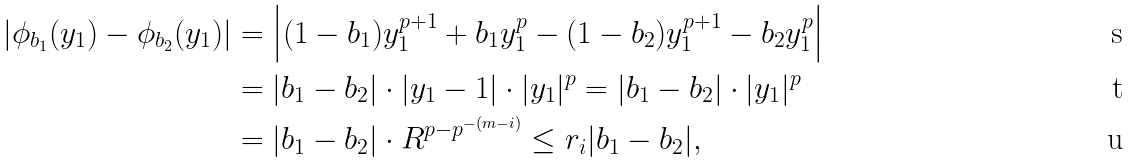<formula> <loc_0><loc_0><loc_500><loc_500>\left | \phi _ { b _ { 1 } } ( y _ { 1 } ) - \phi _ { b _ { 2 } } ( y _ { 1 } ) \right | & = \left | ( 1 - b _ { 1 } ) y _ { 1 } ^ { p + 1 } + b _ { 1 } y _ { 1 } ^ { p } - ( 1 - b _ { 2 } ) y _ { 1 } ^ { p + 1 } - b _ { 2 } y _ { 1 } ^ { p } \right | \\ & = | b _ { 1 } - b _ { 2 } | \cdot | y _ { 1 } - 1 | \cdot | y _ { 1 } | ^ { p } = | b _ { 1 } - b _ { 2 } | \cdot | y _ { 1 } | ^ { p } \\ & = | b _ { 1 } - b _ { 2 } | \cdot R ^ { p - p ^ { - ( m - i ) } } \leq r _ { i } | b _ { 1 } - b _ { 2 } | ,</formula> 